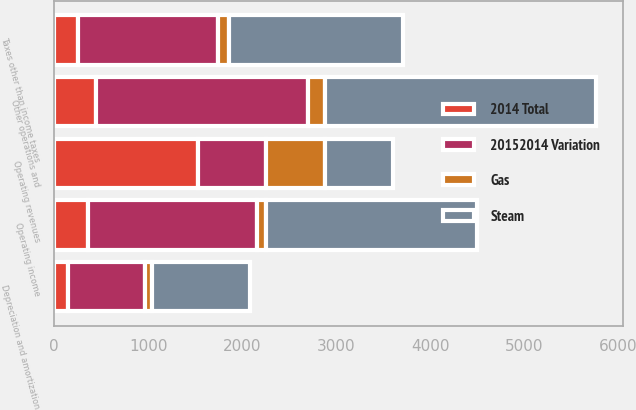<chart> <loc_0><loc_0><loc_500><loc_500><stacked_bar_chart><ecel><fcel>Operating revenues<fcel>Other operations and<fcel>Depreciation and amortization<fcel>Taxes other than income taxes<fcel>Operating income<nl><fcel>20152014 Variation<fcel>724.5<fcel>2259<fcel>820<fcel>1493<fcel>1798<nl><fcel>2014 Total<fcel>1527<fcel>440<fcel>142<fcel>252<fcel>356<nl><fcel>Gas<fcel>629<fcel>182<fcel>78<fcel>111<fcel>93<nl><fcel>Steam<fcel>724.5<fcel>2881<fcel>1040<fcel>1856<fcel>2247<nl></chart> 